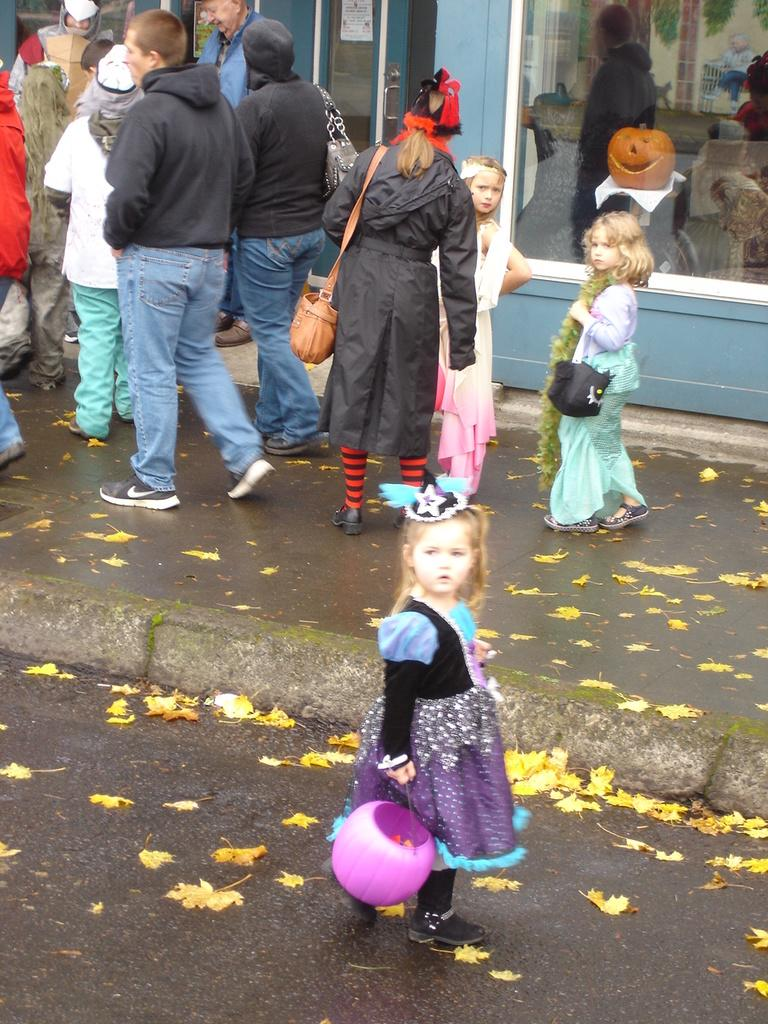Who is the main subject in the foreground of the image? There is a small girl in the foreground of the image. What is the girl doing in the image? The girl is looking at someone. Can you describe the background of the image? There are people standing in the background of the image. What type of pocket can be seen on the floor in the image? There is no pocket visible on the floor in the image. 